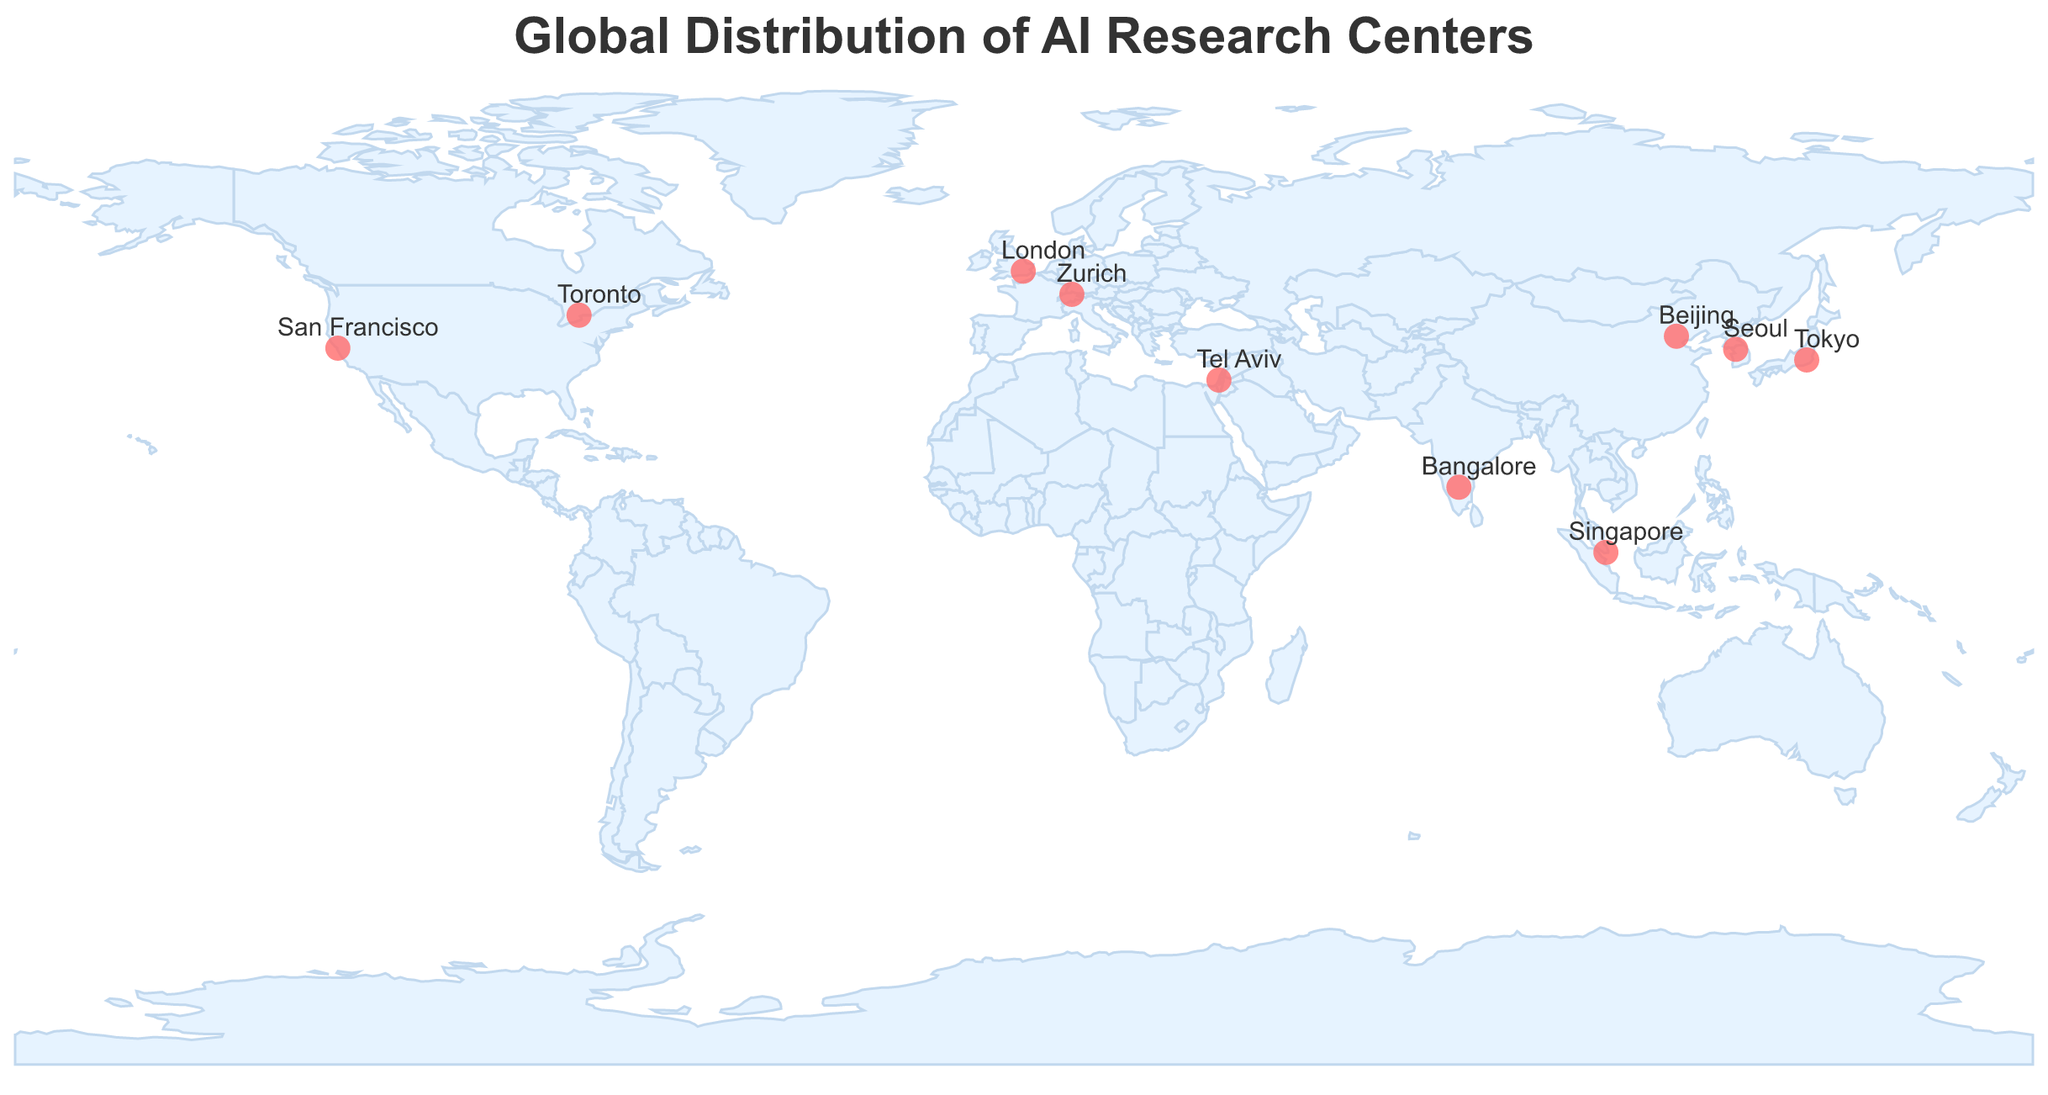What's the title of the figure? The title is often prominently displayed at the top of the figure. From the data provided, the title is specified in the code section under "title" and the "text" attribute.
Answer: Global Distribution of AI Research Centers What city is the research center with specialization in "Neuroscience-inspired AI" located? To find the city, look for the specialization "Neuroscience-inspired AI" in the tooltip or label associated with a circle. The data table indicates that this specialization is linked to the "RIKEN Center for AI Project" located in Tokyo.
Answer: Tokyo Which research center is located in San Francisco? The tooltip or label of the circle placed at the coordinates for San Francisco (-122.4194 longitude and 37.7749 latitude) will provide this information. From the data, it is clear that OpenAI is the research center.
Answer: OpenAI How many research centers specialize in "Natural Language" technologies? Count the research centers under the specialization category that mentions "Natural Language." From the data, there are Google AI Research and AI21 Labs specializing in "Natural Language Processing" and "Natural Language AI" respectively.
Answer: 2 Which research center is in the country known for its city named Tel Aviv? The tooltip or label associated with the circle in Tel Aviv will show the research center. The data indicates that AI21 Labs is located in Tel Aviv, Israel.
Answer: AI21 Labs What research center is known for its specialization in "Reinforcement Learning and Game AI"? Look for the research center with this specialization in the provided data and match it with its tooltip on the figure. From the data table, DeepMind in London is specialized in Reinforcement Learning and Game AI.
Answer: DeepMind Compare the specializations of research centers in Beijing and Bangalore. Which categories do they fall under? To find the specializations, use the tooltips or labels of the circles located in Beijing (China) and Bangalore (India). The data shows Beijing has Tsinghua University AI Institute focused on "Computer Vision and Robotics," while Bangalore has Microsoft Research India focusing on "AI for Social Good."
Answer: Computer Vision and Robotics, AI for Social Good Which city hosts a research center specializing in "AI Ethics and Governance"? Look for the specialization "AI Ethics and Governance" and find the city associated with it in the data. The data shows that KAIST AI Center in Seoul, South Korea, focuses on this specialization.
Answer: Seoul How many research centers are located on the continent of Asia? Count the circles or data points in the figure that represent Asian cities (Beijing, Tokyo, Bangalore, Tel Aviv, Seoul, Singapore). There are 6 such centers in the given data.
Answer: 6 What is the range of latitudes covered by the research centers in the figure? Identify the minimum and maximum latitude values from the data table. From the data, the minimum latitude is 1.3521 (Singapore) and the maximum latitude is 51.5074 (London), giving a range from 1.3521 to 51.5074.
Answer: 1.3521 to 51.5074 